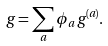<formula> <loc_0><loc_0><loc_500><loc_500>g = \sum _ { a } \phi _ { a } \, g ^ { ( a ) } .</formula> 